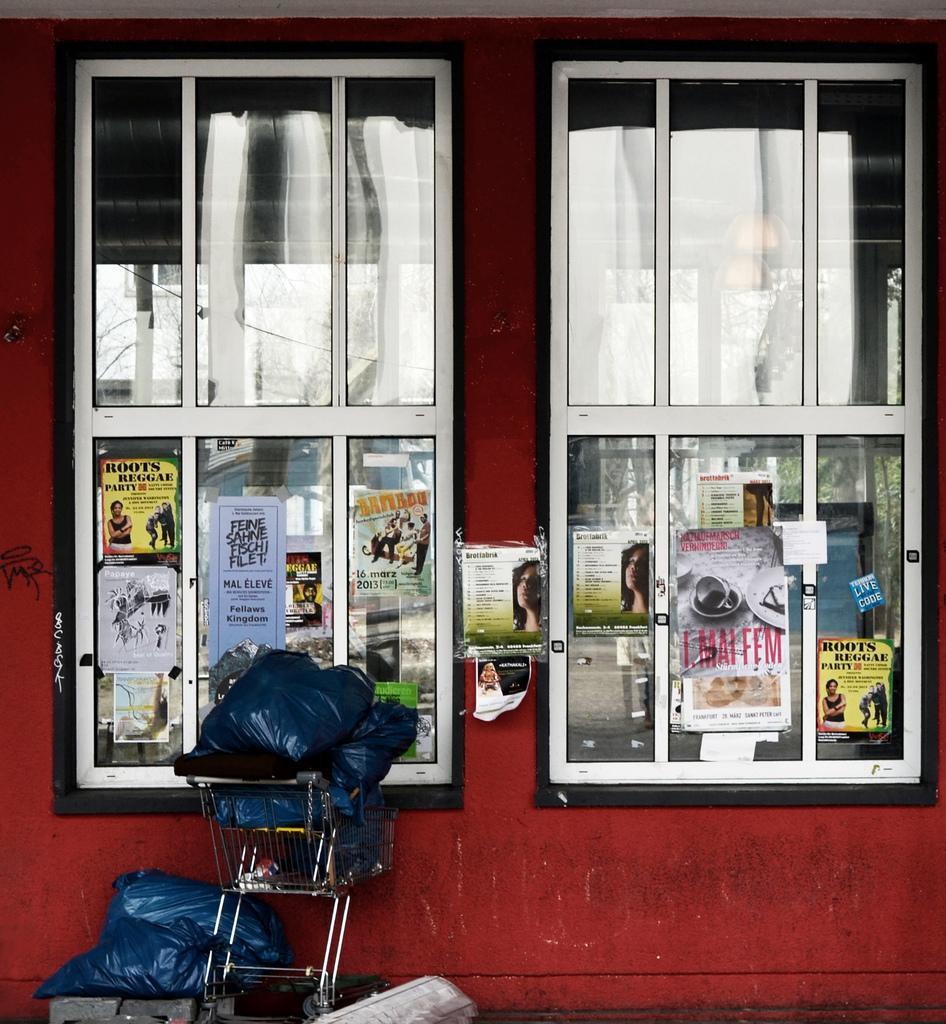Describe this image in one or two sentences. In the center of the image we can see one wheel cart, bags and a few other objects. In the background there is a wall and windows. On the windows, we can see posters and some reflections. 